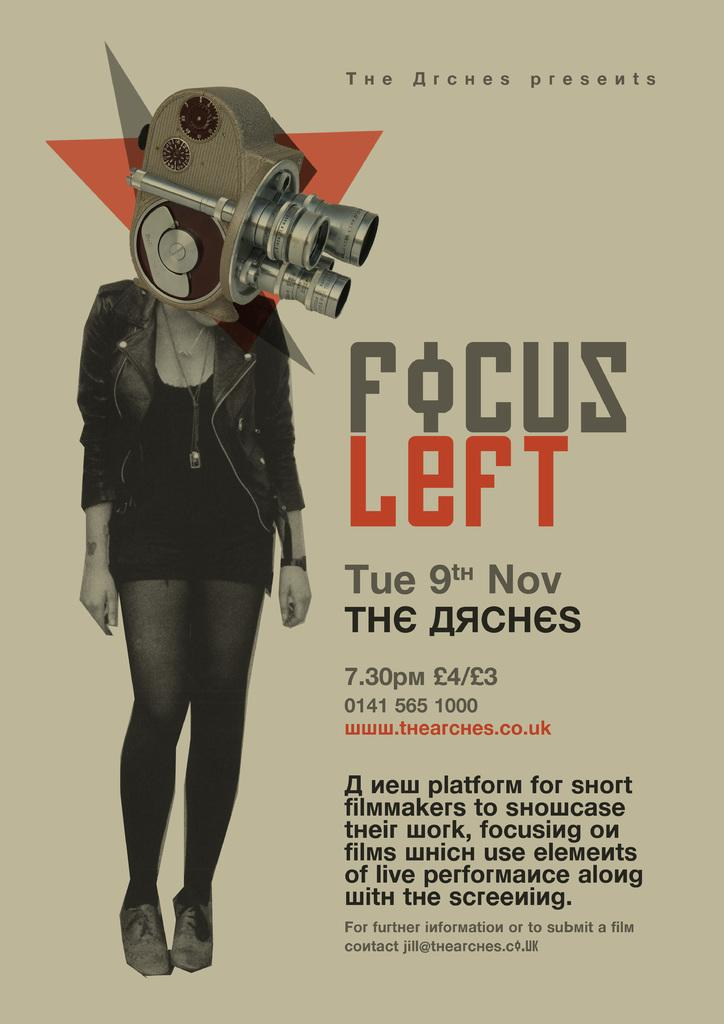What is the main subject of the image? There is a person standing in the image. What else can be seen in the image besides the person? There is a machine in the image. Is there any text present in the image? Yes, there is text written on the image. How many rabbits are sitting on the chairs in the image? There are no chairs or rabbits present in the image. 